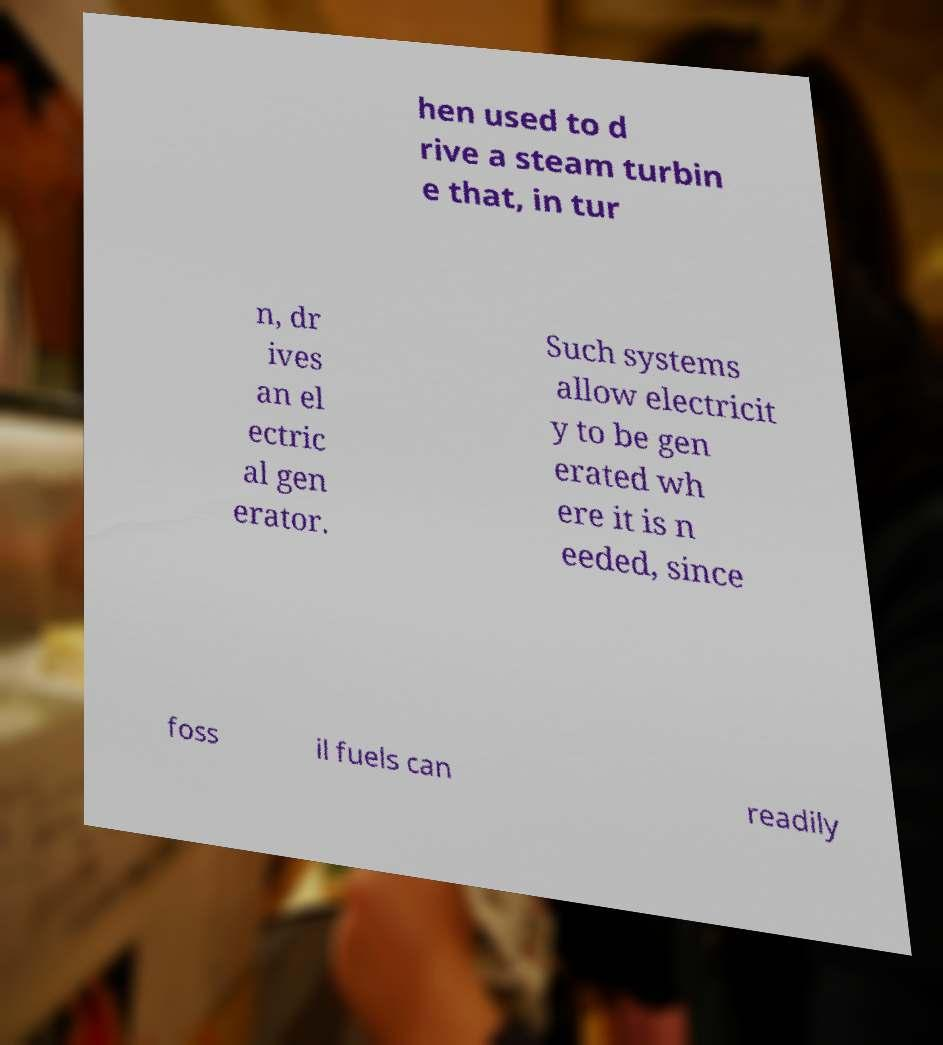I need the written content from this picture converted into text. Can you do that? hen used to d rive a steam turbin e that, in tur n, dr ives an el ectric al gen erator. Such systems allow electricit y to be gen erated wh ere it is n eeded, since foss il fuels can readily 